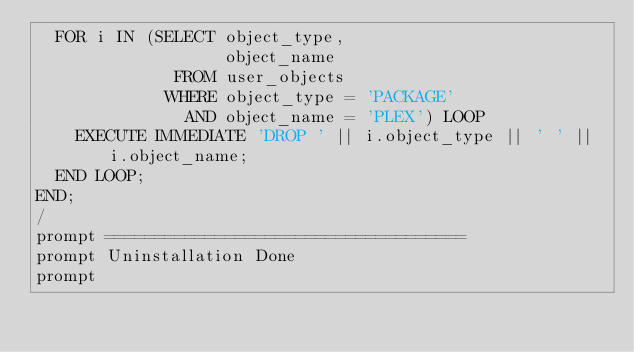Convert code to text. <code><loc_0><loc_0><loc_500><loc_500><_SQL_>  FOR i IN (SELECT object_type,
                   object_name
              FROM user_objects
             WHERE object_type = 'PACKAGE'
               AND object_name = 'PLEX') LOOP
    EXECUTE IMMEDIATE 'DROP ' || i.object_type || ' ' || i.object_name;
  END LOOP;
END;
/
prompt ====================================
prompt Uninstallation Done
prompt</code> 